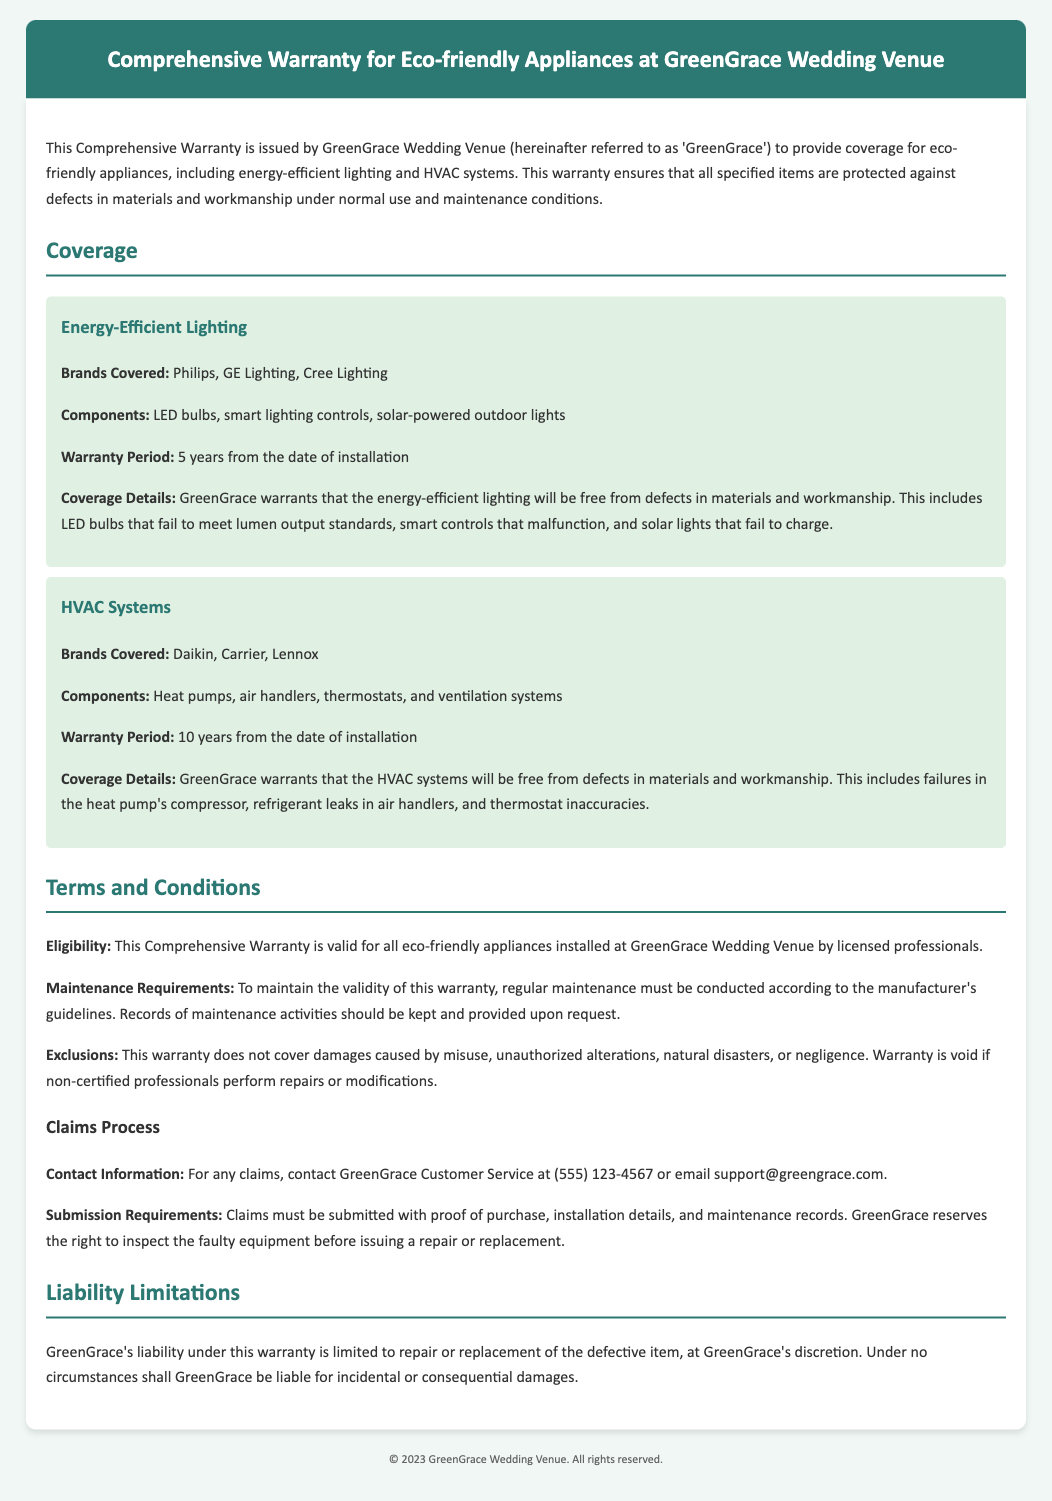What is the warranty period for energy-efficient lighting? The warranty period for energy-efficient lighting is specified to be 5 years from the date of installation.
Answer: 5 years Which brands are covered under the HVAC systems? The document lists Daikin, Carrier, and Lennox as the brands covered under the HVAC systems warranty.
Answer: Daikin, Carrier, Lennox What is excluded from the warranty coverage? The warranty explicitly states that damages caused by misuse, unauthorized alterations, natural disasters, or negligence are excluded.
Answer: Misuse, unauthorized alterations, natural disasters, or negligence What must be kept and provided upon request to maintain warranty validity? Records of maintenance activities must be kept and provided upon request to maintain the warranty validity.
Answer: Maintenance records How long is the warranty for HVAC systems? The warranty period for HVAC systems is specified as 10 years from the date of installation.
Answer: 10 years What is the contact number for claims? The contact number for claims as stated in the document is (555) 123-4567.
Answer: (555) 123-4567 What items are included in the energy-efficient lighting coverage? The coverage for energy-efficient lighting includes LED bulbs, smart lighting controls, and solar-powered outdoor lights.
Answer: LED bulbs, smart lighting controls, solar-powered outdoor lights What should be submitted for a warranty claim? Claims must be submitted with proof of purchase, installation details, and maintenance records as per the document.
Answer: Proof of purchase, installation details, and maintenance records 